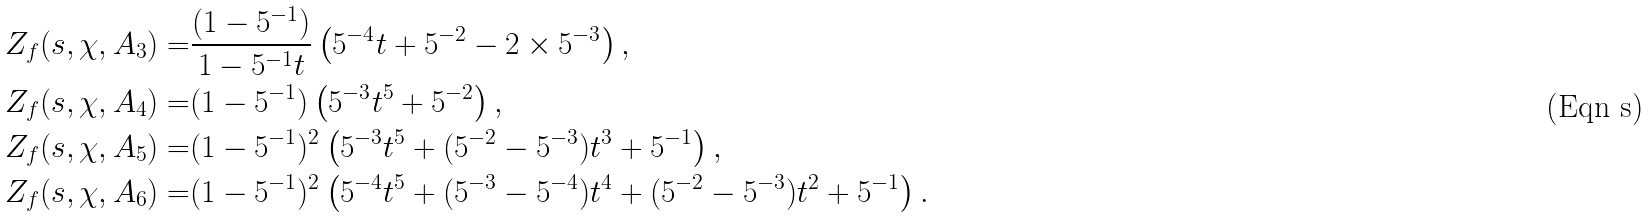Convert formula to latex. <formula><loc_0><loc_0><loc_500><loc_500>Z _ { f } ( s , \chi , A _ { 3 } ) = & \frac { ( 1 - 5 ^ { - 1 } ) } { 1 - 5 ^ { - 1 } t } \left ( 5 ^ { - 4 } t + 5 ^ { - 2 } - 2 \times 5 ^ { - 3 } \right ) , \\ Z _ { f } ( s , \chi , A _ { 4 } ) = & ( 1 - 5 ^ { - 1 } ) \left ( 5 ^ { - 3 } t ^ { 5 } + 5 ^ { - 2 } \right ) , \\ Z _ { f } ( s , \chi , A _ { 5 } ) = & ( 1 - 5 ^ { - 1 } ) ^ { 2 } \left ( 5 ^ { - 3 } t ^ { 5 } + ( 5 ^ { - 2 } - 5 ^ { - 3 } ) t ^ { 3 } + 5 ^ { - 1 } \right ) , \\ Z _ { f } ( s , \chi , A _ { 6 } ) = & ( 1 - 5 ^ { - 1 } ) ^ { 2 } \left ( 5 ^ { - 4 } t ^ { 5 } + ( 5 ^ { - 3 } - 5 ^ { - 4 } ) t ^ { 4 } + ( 5 ^ { - 2 } - 5 ^ { - 3 } ) t ^ { 2 } + 5 ^ { - 1 } \right ) .</formula> 